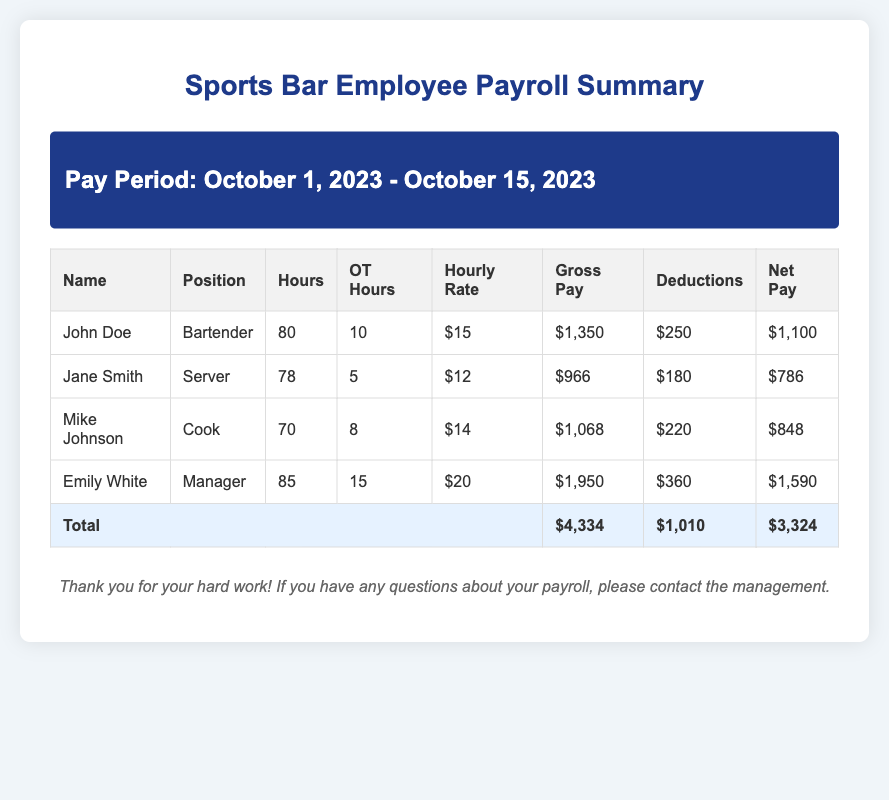what is the total gross pay? The total gross pay is calculated by summing the gross pay for all employees, which is $1,350 + $966 + $1,068 + $1,950 = $4,334.
Answer: $4,334 who is the cook? The cook's name is listed in the document, which is Mike Johnson.
Answer: Mike Johnson how many hours did Emily White work? The document specifies the hours worked by each employee, and Emily White worked a total of 85 hours.
Answer: 85 what is the hourly rate for Jane Smith? The hourly rate for each employee is listed; for Jane Smith, it is $12.
Answer: $12 what is the total net pay? The total net pay is calculated by adding the net pay for all employees, which is $1,100 + $786 + $848 + $1,590 = $3,324.
Answer: $3,324 how many overtime hours did John Doe work? The document provides overtime hours for employees; John Doe worked 10 overtime hours.
Answer: 10 what were the deductions for Mike Johnson? Deductions are specified for each employee, and Mike Johnson's deductions amounted to $220.
Answer: $220 which position has the highest gross pay? The highest gross pay among the employees is provided in the document; it belongs to the Manager position, Emily White, with $1,950.
Answer: Manager what is the pay period for this payroll summary? The document mentions the pay period as October 1, 2023 - October 15, 2023.
Answer: October 1, 2023 - October 15, 2023 